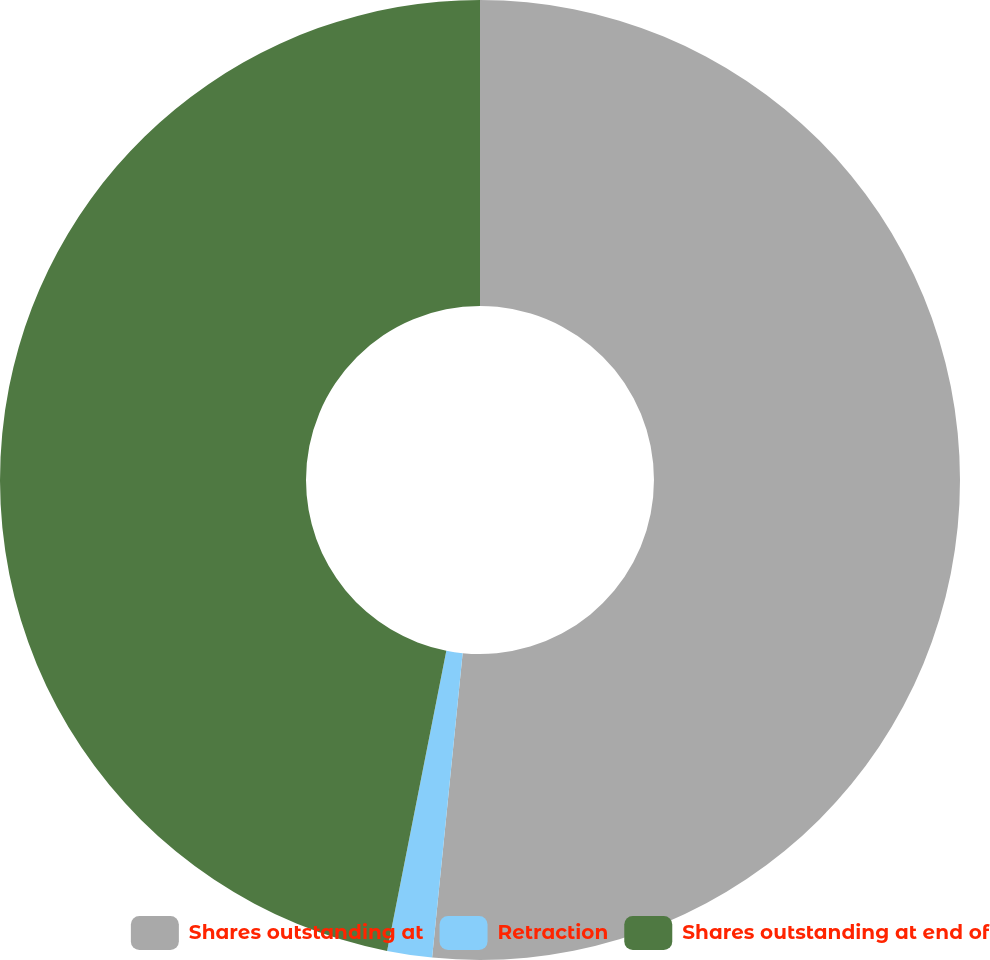Convert chart. <chart><loc_0><loc_0><loc_500><loc_500><pie_chart><fcel>Shares outstanding at<fcel>Retraction<fcel>Shares outstanding at end of<nl><fcel>51.59%<fcel>1.51%<fcel>46.9%<nl></chart> 